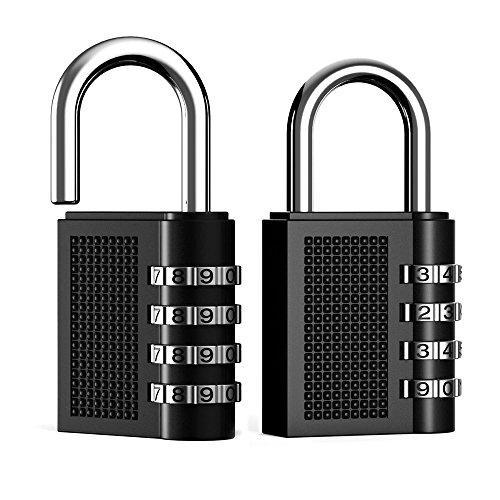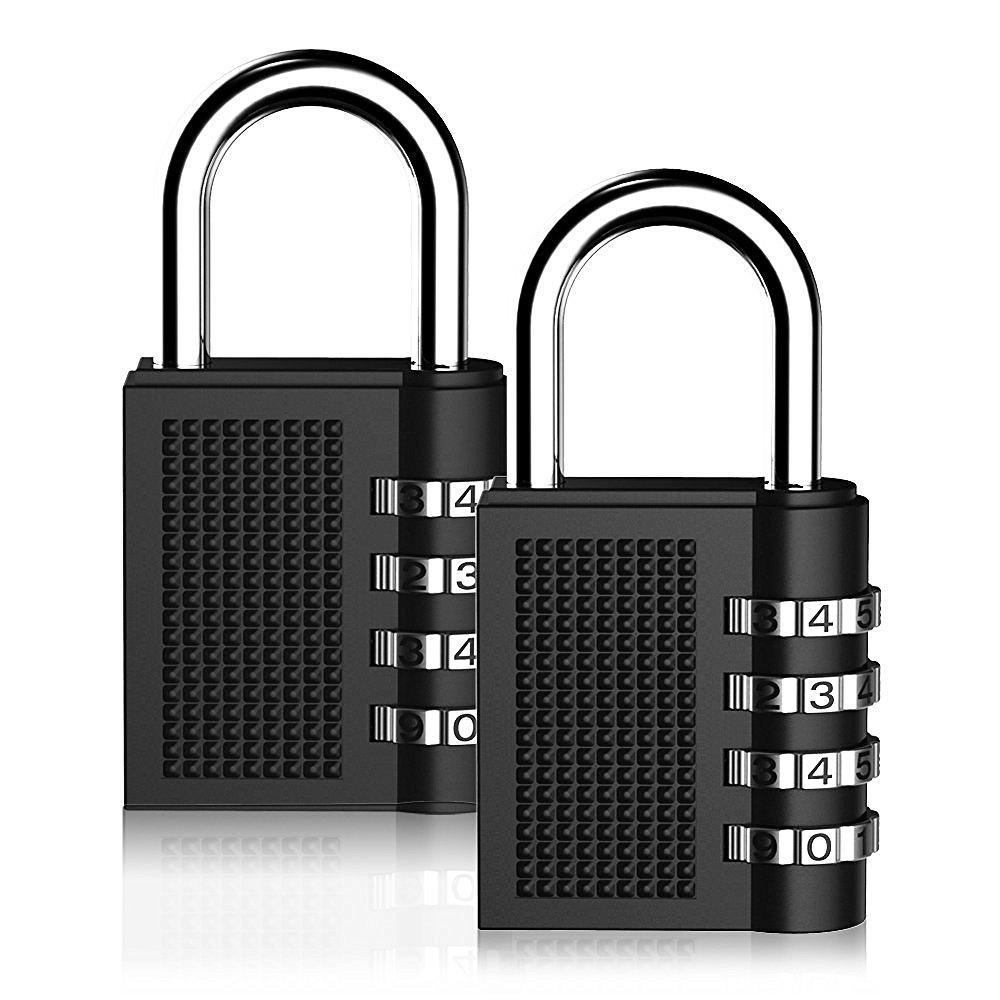The first image is the image on the left, the second image is the image on the right. For the images displayed, is the sentence "We have two combination locks." factually correct? Answer yes or no. No. 